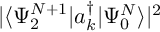Convert formula to latex. <formula><loc_0><loc_0><loc_500><loc_500>| \langle \Psi _ { 2 } ^ { N + 1 } | a _ { k } ^ { \dagger } | \Psi _ { 0 } ^ { N } \rangle | ^ { 2 }</formula> 